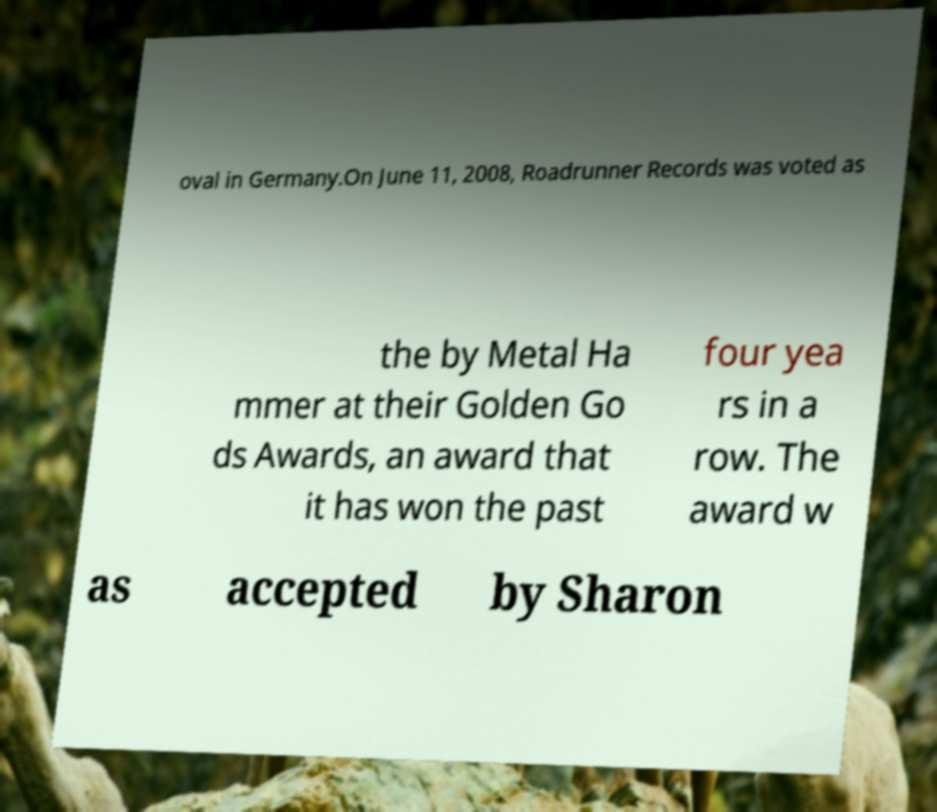Can you accurately transcribe the text from the provided image for me? oval in Germany.On June 11, 2008, Roadrunner Records was voted as the by Metal Ha mmer at their Golden Go ds Awards, an award that it has won the past four yea rs in a row. The award w as accepted by Sharon 